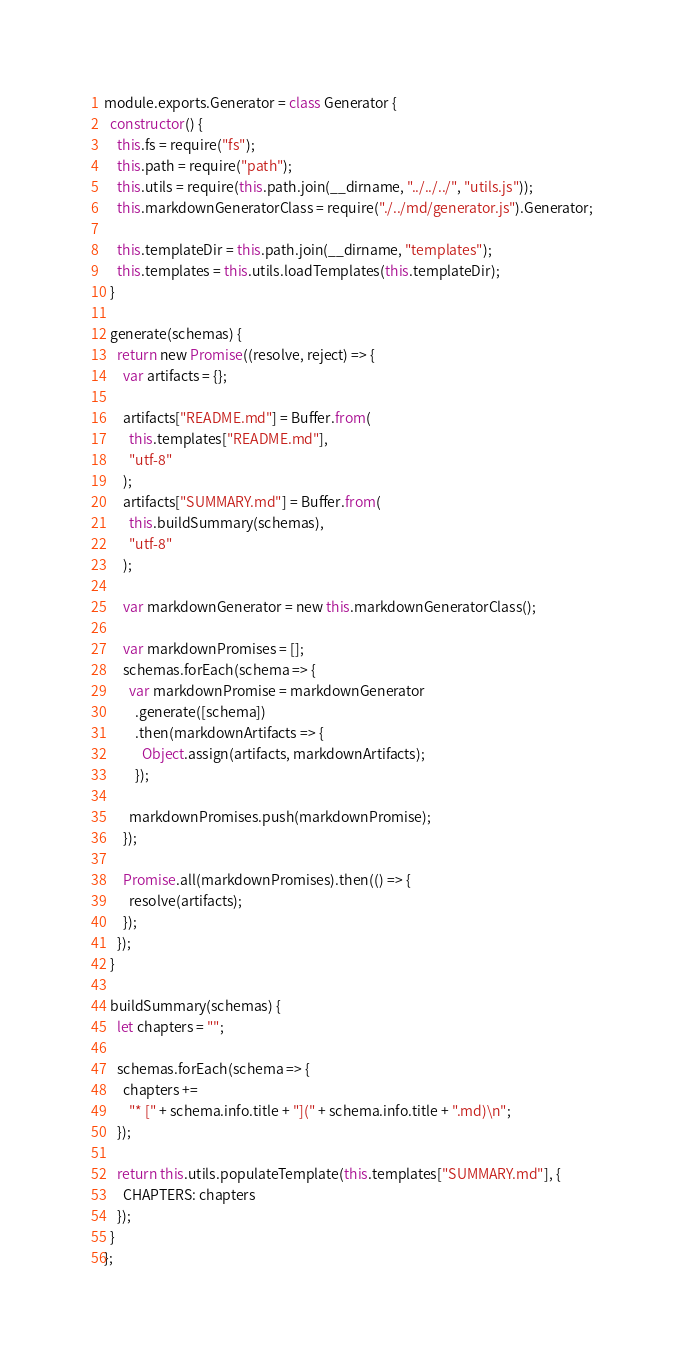Convert code to text. <code><loc_0><loc_0><loc_500><loc_500><_JavaScript_>module.exports.Generator = class Generator {
  constructor() {
    this.fs = require("fs");
    this.path = require("path");
    this.utils = require(this.path.join(__dirname, "../../../", "utils.js"));
    this.markdownGeneratorClass = require("./../md/generator.js").Generator;

    this.templateDir = this.path.join(__dirname, "templates");
    this.templates = this.utils.loadTemplates(this.templateDir);
  }

  generate(schemas) {
    return new Promise((resolve, reject) => {
      var artifacts = {};

      artifacts["README.md"] = Buffer.from(
        this.templates["README.md"],
        "utf-8"
      );
      artifacts["SUMMARY.md"] = Buffer.from(
        this.buildSummary(schemas),
        "utf-8"
      );

      var markdownGenerator = new this.markdownGeneratorClass();

      var markdownPromises = [];
      schemas.forEach(schema => {
        var markdownPromise = markdownGenerator
          .generate([schema])
          .then(markdownArtifacts => {
            Object.assign(artifacts, markdownArtifacts);
          });

        markdownPromises.push(markdownPromise);
      });

      Promise.all(markdownPromises).then(() => {
        resolve(artifacts);
      });
    });
  }

  buildSummary(schemas) {
    let chapters = "";

    schemas.forEach(schema => {
      chapters +=
        "* [" + schema.info.title + "](" + schema.info.title + ".md)\n";
    });

    return this.utils.populateTemplate(this.templates["SUMMARY.md"], {
      CHAPTERS: chapters
    });
  }
};
</code> 